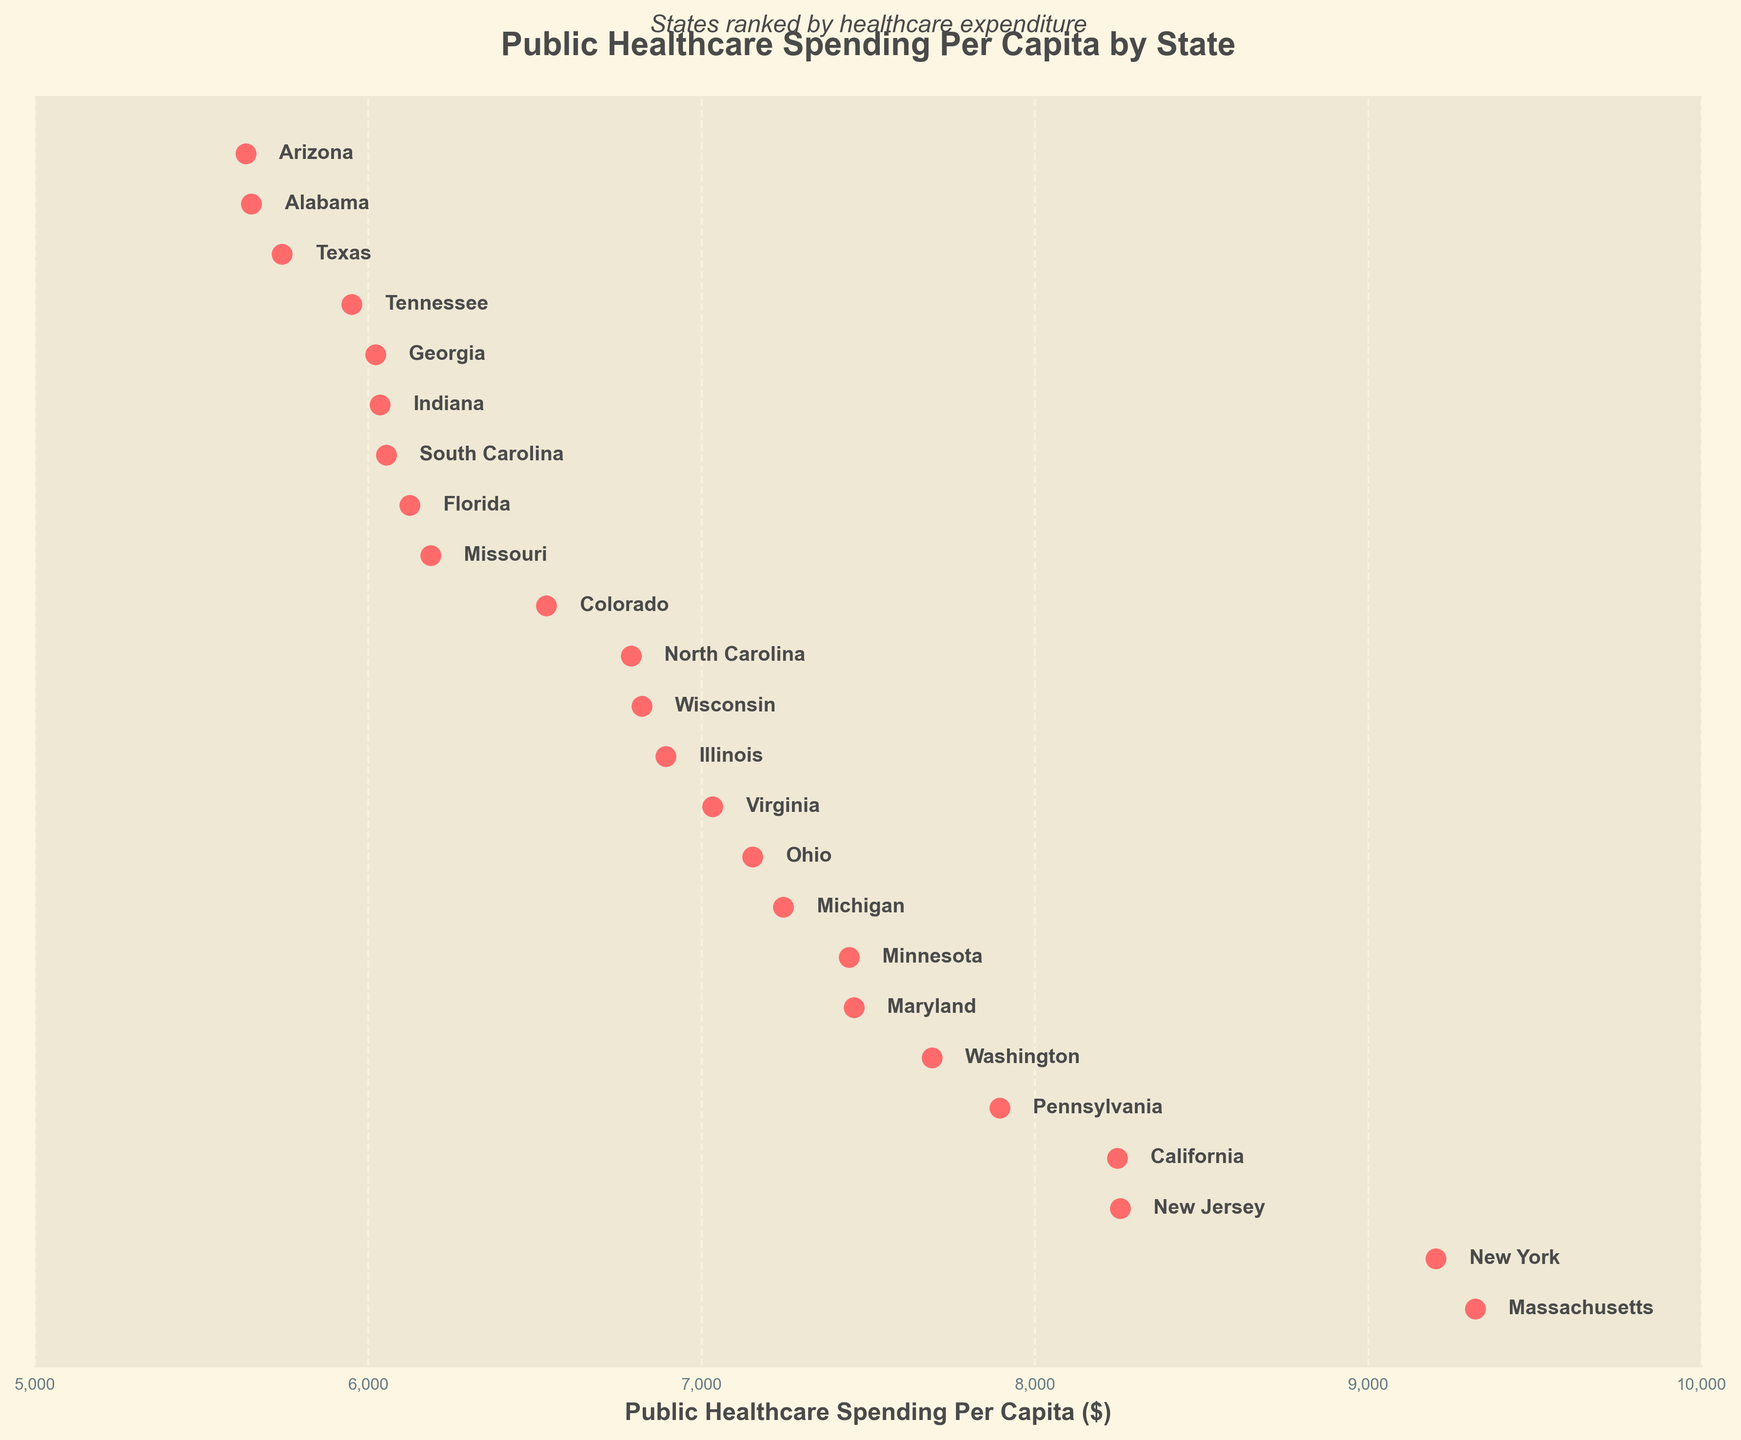What is the title of the plot? The title of the plot is located at the top and reads "Public Healthcare Spending Per Capita by State."
Answer: Public Healthcare Spending Per Capita by State Which state has the highest public healthcare spending per capita? The state with the highest dot on the plot corresponds to Massachusetts.
Answer: Massachusetts Which state spends the least on public healthcare per capita? The state with the lowest dot on the plot corresponds to Arizona.
Answer: Arizona How much does New York spend on public healthcare per capita? Locate the dot and label for New York, which is near the top of the plot. The spending is indicated as 9203.
Answer: 9203 What is the difference in public healthcare spending between New Jersey and Arizona? Identify the spending for New Jersey (8256) and Arizona (5632) from their respective dots. Subtract the smaller value from the larger one: 8256 - 5632 = 2624.
Answer: 2624 What are the states that spend more than $8000 on public healthcare per capita? Identify the states with dots to the right of the $8000 mark. These are New York, New Jersey, and Massachusetts.
Answer: New York, New Jersey, Massachusetts Is the public healthcare spending for California higher or lower than for Pennsylvania? Identify the spending amounts for California (8247) and Pennsylvania (7894). Compare the values; California's spending is higher.
Answer: Higher What is the average public healthcare spending per capita for the three states with the highest spending? The top three states are Massachusetts (9321), New York (9203), and New Jersey (8256). Calculate the average: (9321 + 9203 + 8256) / 3 = 8926.67.
Answer: 8926.67 How many states have public healthcare spending between $6000 and $7000 per capita? Identify the dots that fall within the $6000 to $7000 range. These states are Florida, Georgia, Indiana, Missouri, and Wisconsin, totaling 5 states.
Answer: 5 Which states have roughly similar public healthcare spending per capita around $7400? Find states whose dots are close to the $7400 mark. These states are Minnesota and Maryland.
Answer: Minnesota, Maryland 